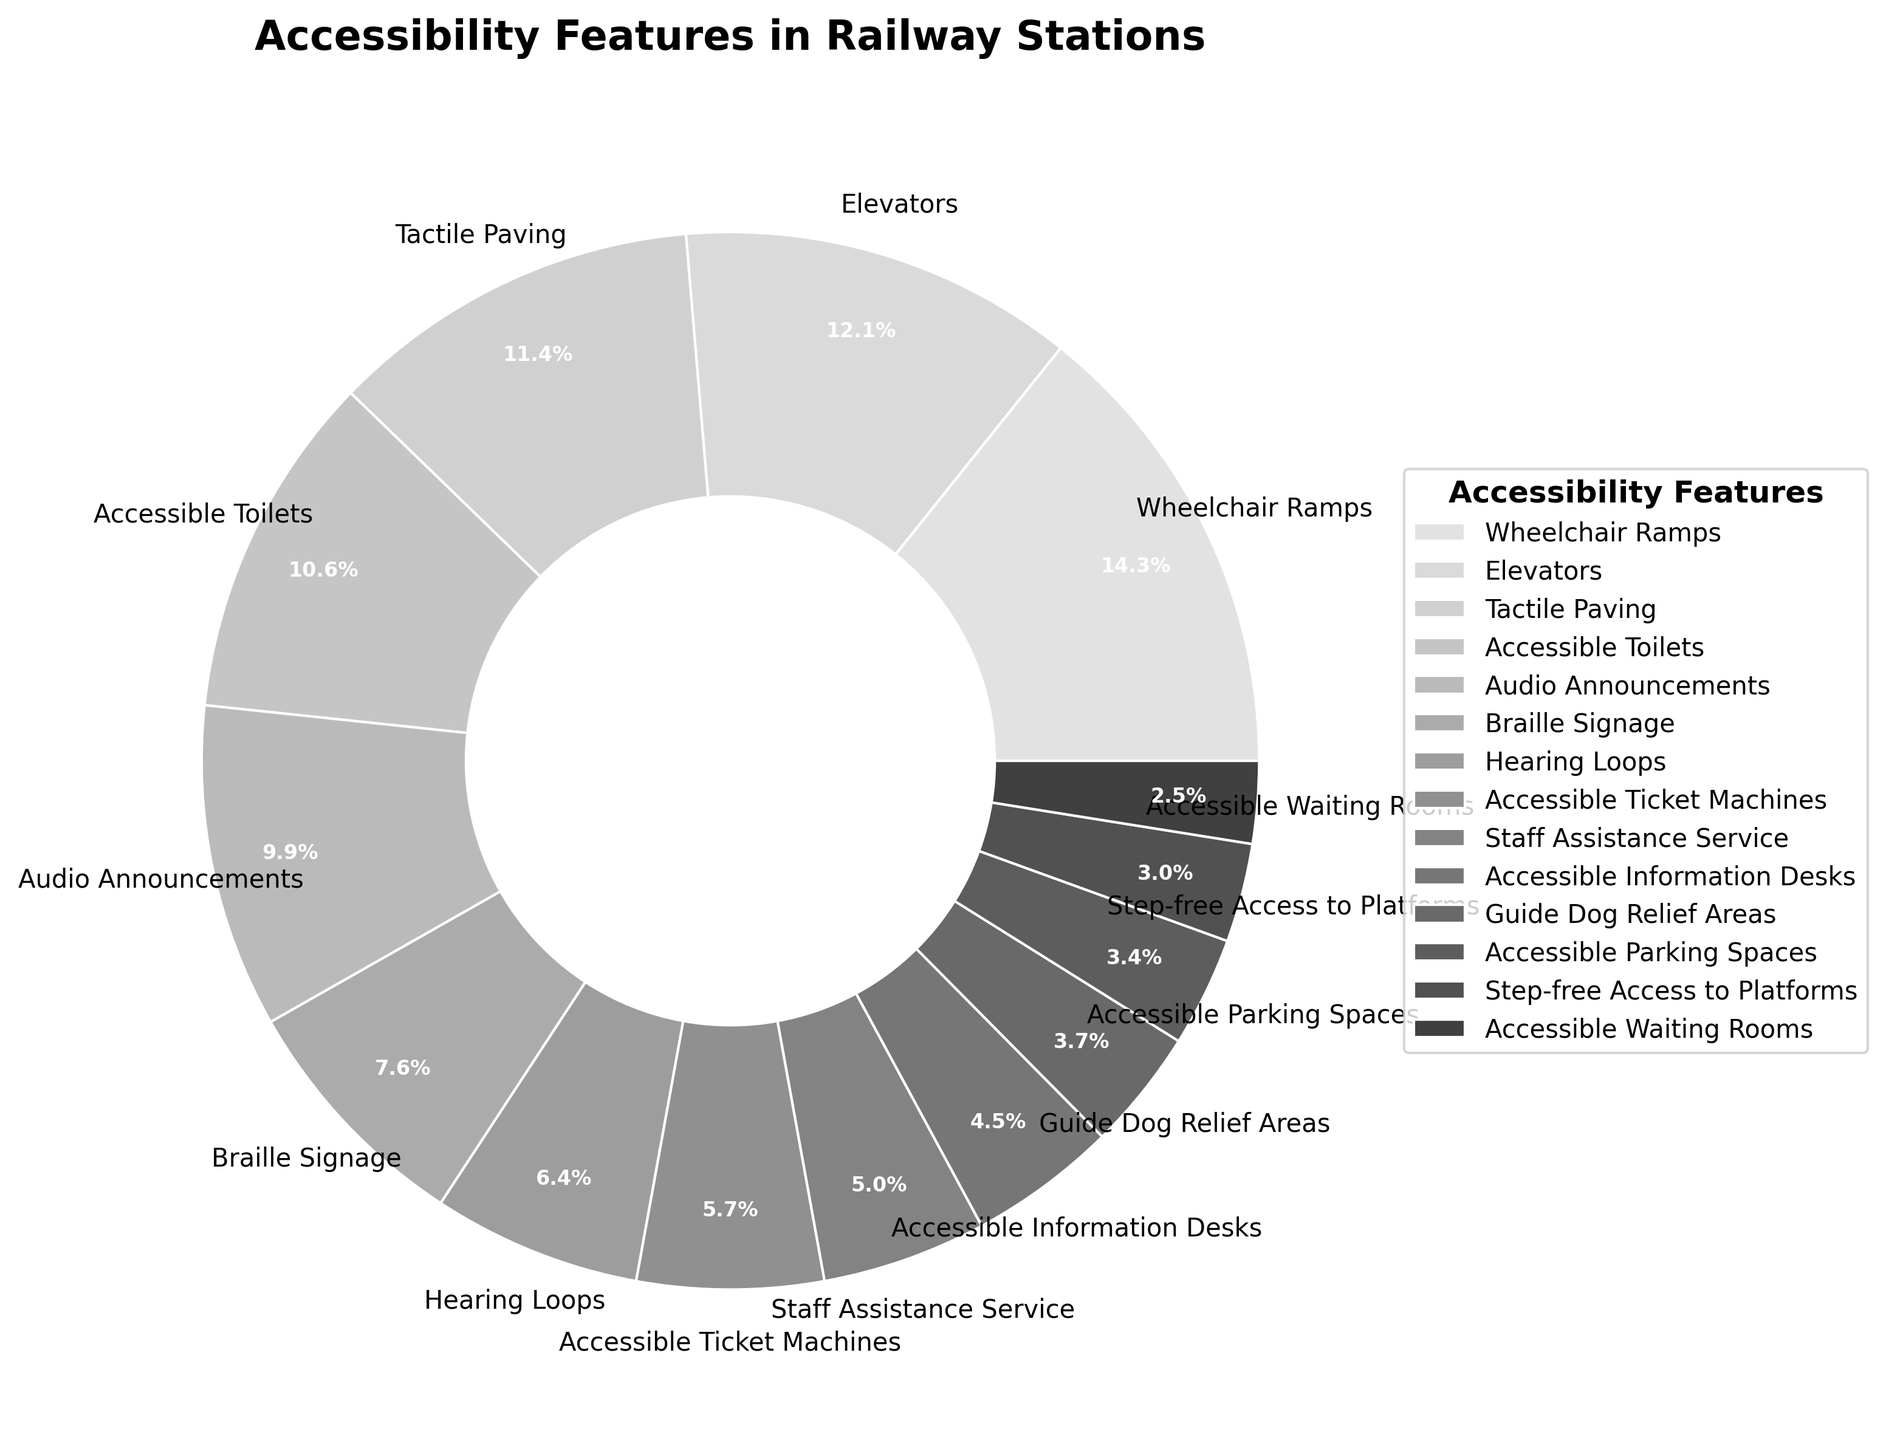Which accessibility feature is the most common in railway stations? The feature with the highest percentage in the pie chart is the most common. According to the chart, "Wheelchair Ramps" has the highest percentage.
Answer: Wheelchair Ramps What is the difference in percentage between the most and least common accessibility features? To find the difference, subtract the percentage of the least common feature from the percentage of the most common feature. The most common feature is "Wheelchair Ramps" (85%) and the least common is "Accessible Waiting Rooms" (15%). The difference is 85% - 15% = 70%.
Answer: 70% Which features have less than 50% implementation in railway stations? Look for the features on the pie chart that have percentages less than 50%. These include "Braille Signage", "Hearing Loops", "Accessible Ticket Machines", "Staff Assistance Service", "Accessible Information Desks", "Guide Dog Relief Areas", "Accessible Parking Spaces", "Step-free Access to Platforms", "Accessible Waiting Rooms".
Answer: Braille Signage, Hearing Loops, Accessible Ticket Machines, Staff Assistance Service, Accessible Information Desks, Guide Dog Relief Areas, Accessible Parking Spaces, Step-free Access to Platforms, Accessible Waiting Rooms How many features have more than 60% implementation? To find this, count the features in the pie chart that have percentages greater than 60%. These are "Wheelchair Ramps" (85%), "Elevators" (72%), "Tactile Paving" (68%), and "Accessible Toilets" (63%). There are four such features.
Answer: 4 Which has a higher percentage, "Audio Announcements" or "Braille Signage"? Compare the percentages of "Audio Announcements" (59%) and "Braille Signage" (45%) as shown in the pie chart.
Answer: Audio Announcements Are there more features above 50% or below 50% implementation? Count the features above 50% and the features below 50% in the pie chart. There are four features above 50%: "Wheelchair Ramps" (85%), "Elevators" (72%), "Tactile Paving" (68%), and "Accessible Toilets" (63%). There are more features below 50%, specifically: "Audio Announcements" (59%), "Braille Signage" (45%), "Hearing Loops" (38%), "Accessible Ticket Machines" (34%), "Staff Assistance Service" (30%), "Accessible Information Desks" (27%), "Guide Dog Relief Areas" (22%), "Accessible Parking Spaces" (20%), "Step-free Access to Platforms" (18%), and "Accessible Waiting Rooms" (15%). The count is 4 above and 10 below.
Answer: Below What is the combined percentage of "Elevators" and "Tactile Paving"? Add the percentages of "Elevators" (72%) and "Tactile Paving" (68%) as shown in the pie chart. The combined percentage is 72% + 68% = 140%.
Answer: 140% 